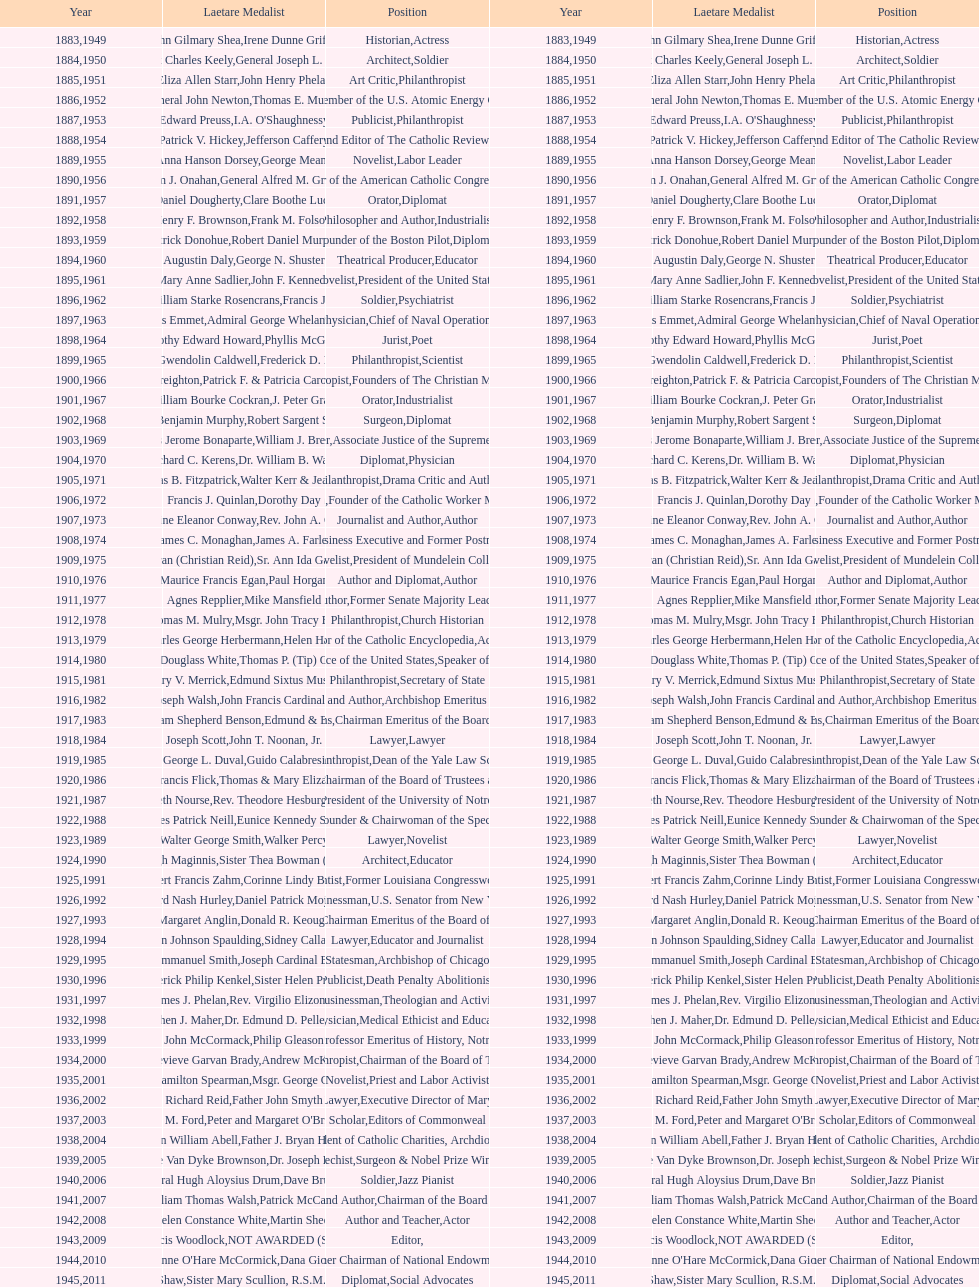What is the name of the laetare medalist mentioned before edward preuss? General John Newton. 